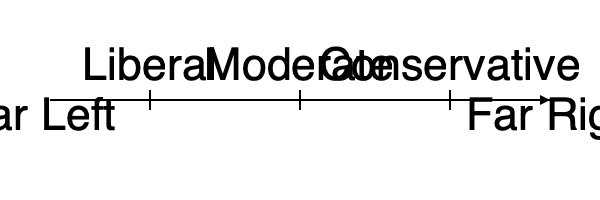Based on the political ideology spectrum shown in the diagram, which position would be considered the most centrist or neutral? To determine the most centrist or neutral position on the political ideology spectrum, we need to follow these steps:

1. Understand the spectrum: The diagram shows a linear scale from Far Left to Far Right, representing the range of political ideologies.

2. Identify the labeled positions: The spectrum includes three labeled positions - Liberal, Moderate, and Conservative.

3. Analyze the positions:
   a. Liberal is positioned to the left of center.
   b. Conservative is positioned to the right of center.
   c. Moderate is positioned in the middle of the spectrum.

4. Consider the meaning of "centrist" or "neutral":
   a. Centrist refers to a political position that is in the center of the spectrum.
   b. Neutral implies a balanced position between opposing viewpoints.

5. Compare the labeled positions:
   a. Liberal and Conservative are not in the center, as they lean towards opposite ends of the spectrum.
   b. Moderate is positioned in the middle, equidistant from both extremes.

6. Conclude: The Moderate position is the most centrist or neutral on this political ideology spectrum.
Answer: Moderate 